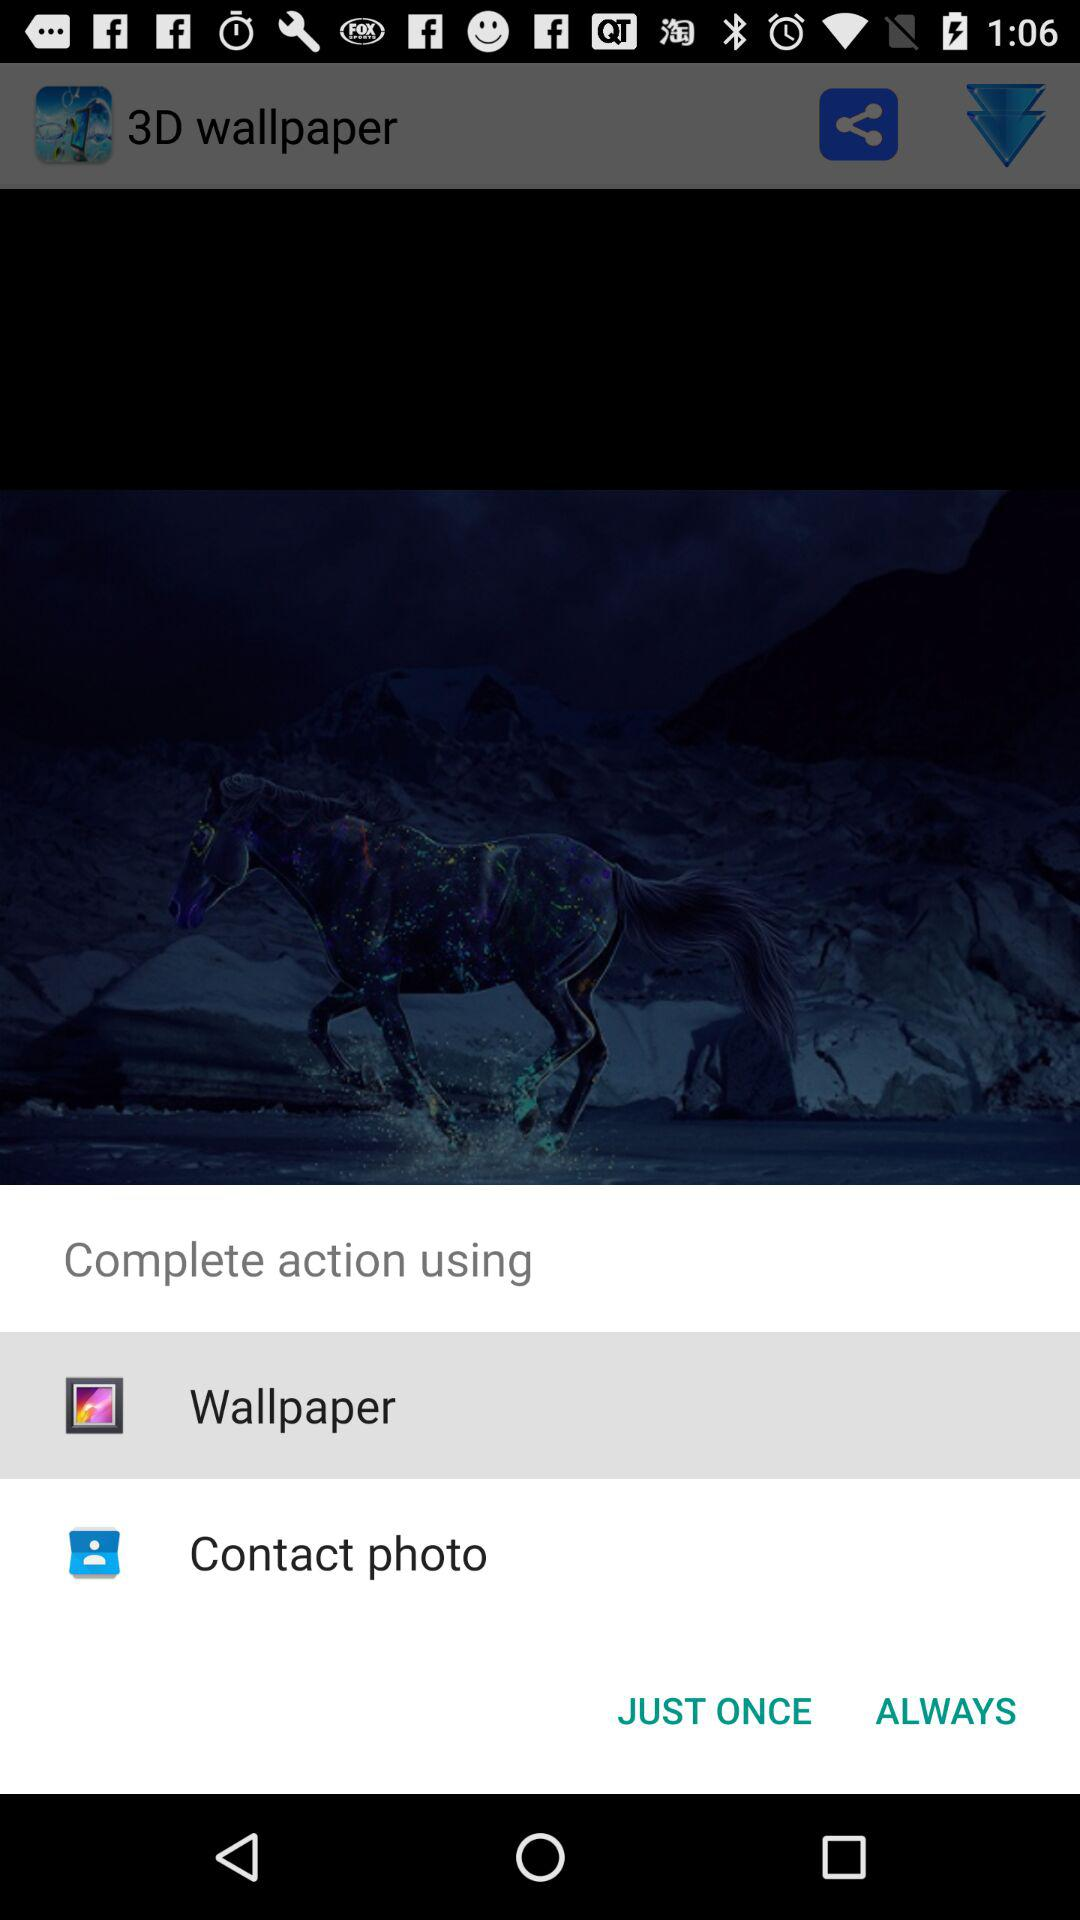Through which application can we complete the action? You can complete the action using "Wallpaper" and "Contact photo". 